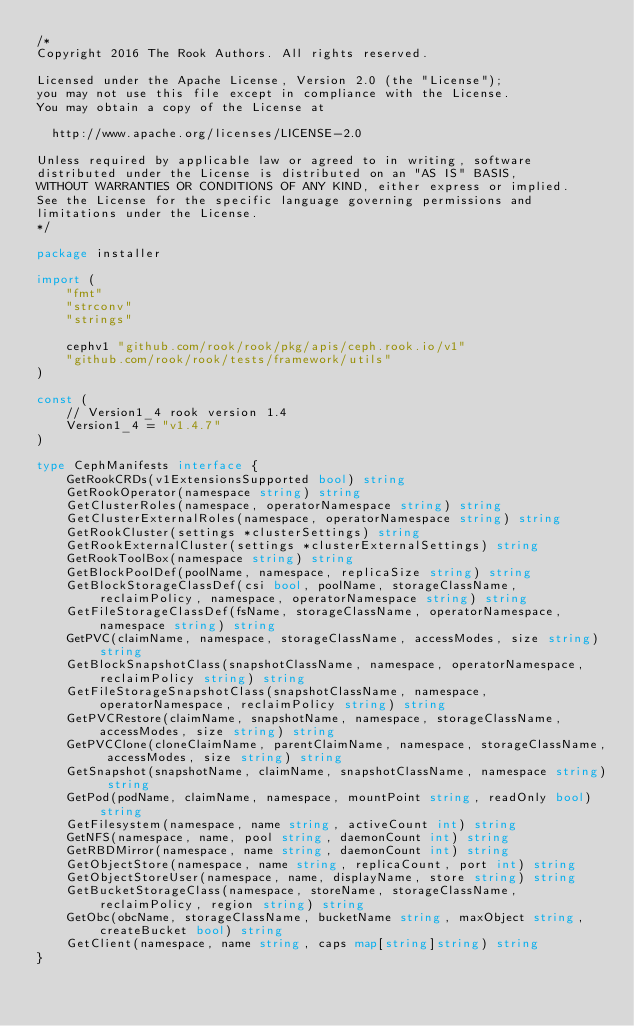Convert code to text. <code><loc_0><loc_0><loc_500><loc_500><_Go_>/*
Copyright 2016 The Rook Authors. All rights reserved.

Licensed under the Apache License, Version 2.0 (the "License");
you may not use this file except in compliance with the License.
You may obtain a copy of the License at

  http://www.apache.org/licenses/LICENSE-2.0

Unless required by applicable law or agreed to in writing, software
distributed under the License is distributed on an "AS IS" BASIS,
WITHOUT WARRANTIES OR CONDITIONS OF ANY KIND, either express or implied.
See the License for the specific language governing permissions and
limitations under the License.
*/

package installer

import (
	"fmt"
	"strconv"
	"strings"

	cephv1 "github.com/rook/rook/pkg/apis/ceph.rook.io/v1"
	"github.com/rook/rook/tests/framework/utils"
)

const (
	// Version1_4 rook version 1.4
	Version1_4 = "v1.4.7"
)

type CephManifests interface {
	GetRookCRDs(v1ExtensionsSupported bool) string
	GetRookOperator(namespace string) string
	GetClusterRoles(namespace, operatorNamespace string) string
	GetClusterExternalRoles(namespace, operatorNamespace string) string
	GetRookCluster(settings *clusterSettings) string
	GetRookExternalCluster(settings *clusterExternalSettings) string
	GetRookToolBox(namespace string) string
	GetBlockPoolDef(poolName, namespace, replicaSize string) string
	GetBlockStorageClassDef(csi bool, poolName, storageClassName, reclaimPolicy, namespace, operatorNamespace string) string
	GetFileStorageClassDef(fsName, storageClassName, operatorNamespace, namespace string) string
	GetPVC(claimName, namespace, storageClassName, accessModes, size string) string
	GetBlockSnapshotClass(snapshotClassName, namespace, operatorNamespace, reclaimPolicy string) string
	GetFileStorageSnapshotClass(snapshotClassName, namespace, operatorNamespace, reclaimPolicy string) string
	GetPVCRestore(claimName, snapshotName, namespace, storageClassName, accessModes, size string) string
	GetPVCClone(cloneClaimName, parentClaimName, namespace, storageClassName, accessModes, size string) string
	GetSnapshot(snapshotName, claimName, snapshotClassName, namespace string) string
	GetPod(podName, claimName, namespace, mountPoint string, readOnly bool) string
	GetFilesystem(namespace, name string, activeCount int) string
	GetNFS(namespace, name, pool string, daemonCount int) string
	GetRBDMirror(namespace, name string, daemonCount int) string
	GetObjectStore(namespace, name string, replicaCount, port int) string
	GetObjectStoreUser(namespace, name, displayName, store string) string
	GetBucketStorageClass(namespace, storeName, storageClassName, reclaimPolicy, region string) string
	GetObc(obcName, storageClassName, bucketName string, maxObject string, createBucket bool) string
	GetClient(namespace, name string, caps map[string]string) string
}
</code> 